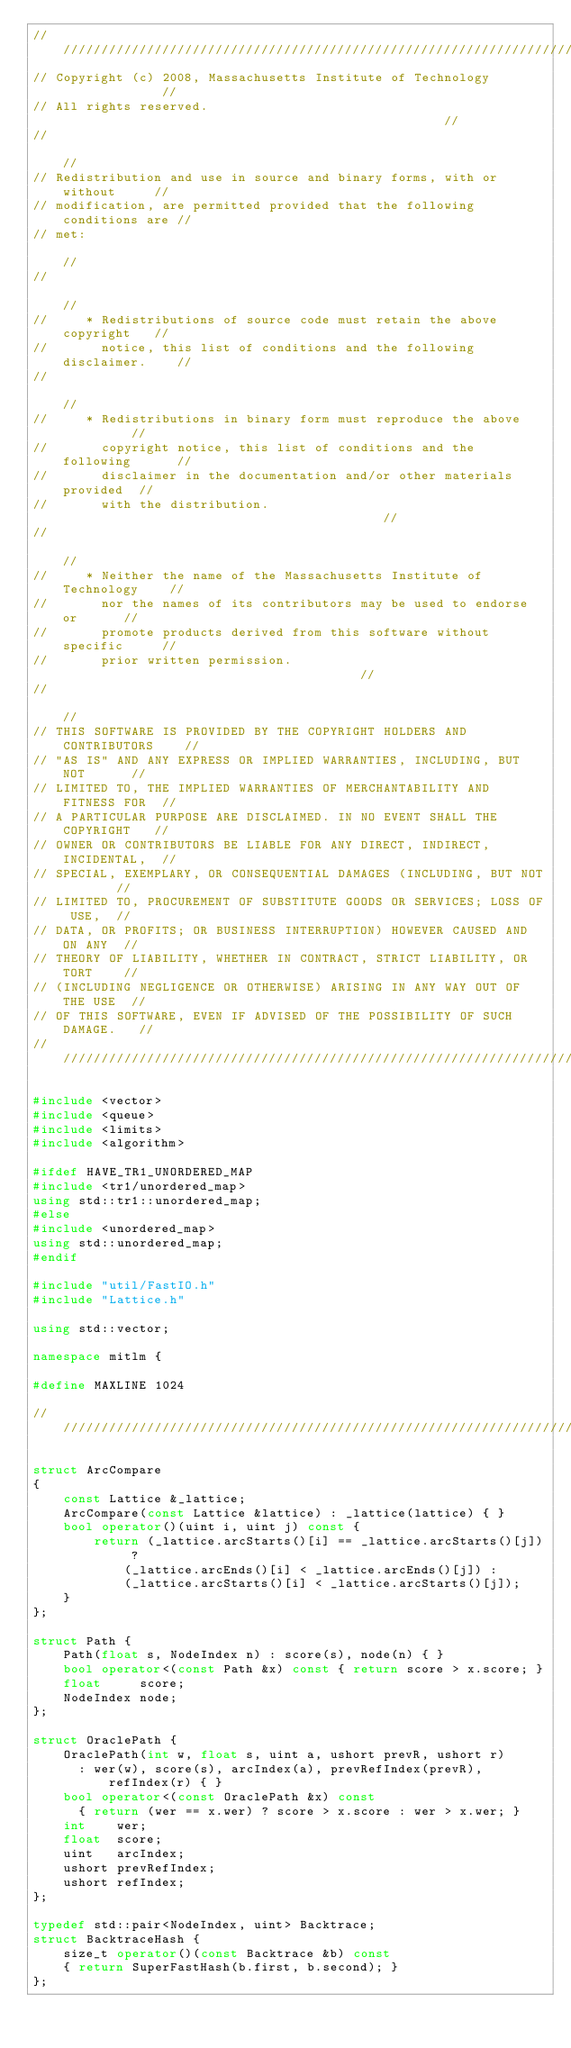Convert code to text. <code><loc_0><loc_0><loc_500><loc_500><_C++_>//////////////////////////////////////////////////////////////////////////
// Copyright (c) 2008, Massachusetts Institute of Technology              //
// All rights reserved.                                                   //
//                                                                        //
// Redistribution and use in source and binary forms, with or without     //
// modification, are permitted provided that the following conditions are //
// met:                                                                   //
//                                                                        //
//     * Redistributions of source code must retain the above copyright   //
//       notice, this list of conditions and the following disclaimer.    //
//                                                                        //
//     * Redistributions in binary form must reproduce the above          //
//       copyright notice, this list of conditions and the following      //
//       disclaimer in the documentation and/or other materials provided  //
//       with the distribution.                                           //
//                                                                        //
//     * Neither the name of the Massachusetts Institute of Technology    //
//       nor the names of its contributors may be used to endorse or      //
//       promote products derived from this software without specific     //
//       prior written permission.                                        //
//                                                                        //
// THIS SOFTWARE IS PROVIDED BY THE COPYRIGHT HOLDERS AND CONTRIBUTORS    //
// "AS IS" AND ANY EXPRESS OR IMPLIED WARRANTIES, INCLUDING, BUT NOT      //
// LIMITED TO, THE IMPLIED WARRANTIES OF MERCHANTABILITY AND FITNESS FOR  //
// A PARTICULAR PURPOSE ARE DISCLAIMED. IN NO EVENT SHALL THE COPYRIGHT   //
// OWNER OR CONTRIBUTORS BE LIABLE FOR ANY DIRECT, INDIRECT, INCIDENTAL,  //
// SPECIAL, EXEMPLARY, OR CONSEQUENTIAL DAMAGES (INCLUDING, BUT NOT       //
// LIMITED TO, PROCUREMENT OF SUBSTITUTE GOODS OR SERVICES; LOSS OF USE,  //
// DATA, OR PROFITS; OR BUSINESS INTERRUPTION) HOWEVER CAUSED AND ON ANY  //
// THEORY OF LIABILITY, WHETHER IN CONTRACT, STRICT LIABILITY, OR TORT    //
// (INCLUDING NEGLIGENCE OR OTHERWISE) ARISING IN ANY WAY OUT OF THE USE  //
// OF THIS SOFTWARE, EVEN IF ADVISED OF THE POSSIBILITY OF SUCH DAMAGE.   //
////////////////////////////////////////////////////////////////////////////

#include <vector>
#include <queue>
#include <limits>
#include <algorithm>

#ifdef HAVE_TR1_UNORDERED_MAP
#include <tr1/unordered_map>
using std::tr1::unordered_map;
#else
#include <unordered_map>
using std::unordered_map;
#endif

#include "util/FastIO.h"
#include "Lattice.h"

using std::vector;

namespace mitlm {

#define MAXLINE 1024

////////////////////////////////////////////////////////////////////////////////

struct ArcCompare
{
    const Lattice &_lattice;
    ArcCompare(const Lattice &lattice) : _lattice(lattice) { }
    bool operator()(uint i, uint j) const {
        return (_lattice.arcStarts()[i] == _lattice.arcStarts()[j]) ?
            (_lattice.arcEnds()[i] < _lattice.arcEnds()[j]) :
            (_lattice.arcStarts()[i] < _lattice.arcStarts()[j]);
    }
};

struct Path {
    Path(float s, NodeIndex n) : score(s), node(n) { }
    bool operator<(const Path &x) const { return score > x.score; }
    float     score;
    NodeIndex node;
};

struct OraclePath {
    OraclePath(int w, float s, uint a, ushort prevR, ushort r)
      : wer(w), score(s), arcIndex(a), prevRefIndex(prevR), refIndex(r) { }
    bool operator<(const OraclePath &x) const
      { return (wer == x.wer) ? score > x.score : wer > x.wer; }
    int    wer;
    float  score;
    uint   arcIndex;
    ushort prevRefIndex;
    ushort refIndex;
};

typedef std::pair<NodeIndex, uint> Backtrace;
struct BacktraceHash {
    size_t operator()(const Backtrace &b) const
    { return SuperFastHash(b.first, b.second); }
};
</code> 